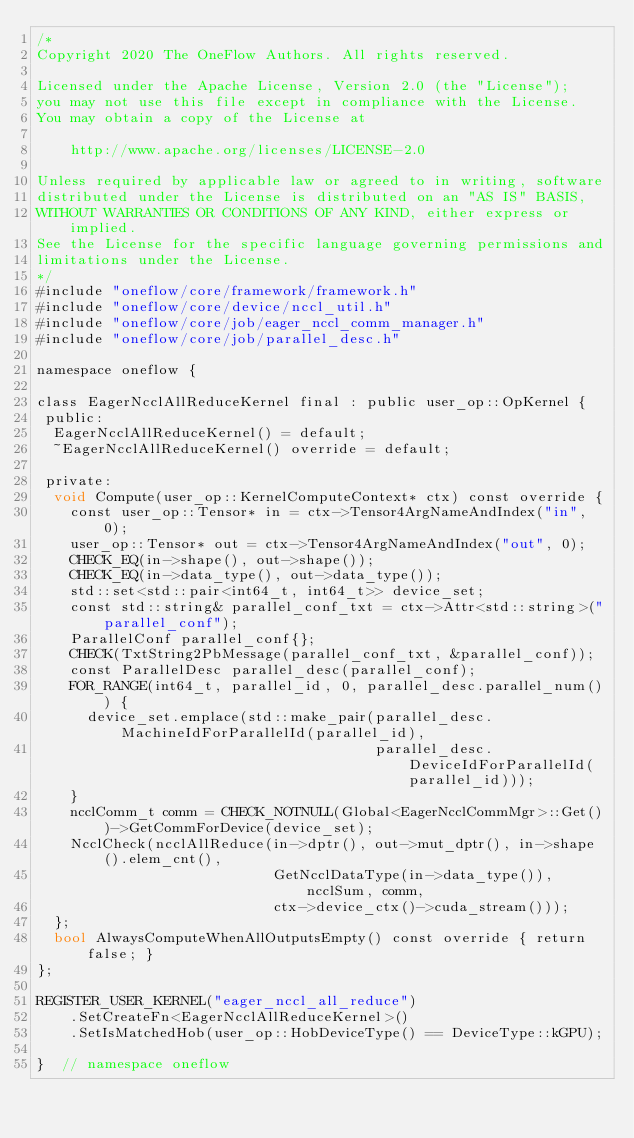Convert code to text. <code><loc_0><loc_0><loc_500><loc_500><_Cuda_>/*
Copyright 2020 The OneFlow Authors. All rights reserved.

Licensed under the Apache License, Version 2.0 (the "License");
you may not use this file except in compliance with the License.
You may obtain a copy of the License at

    http://www.apache.org/licenses/LICENSE-2.0

Unless required by applicable law or agreed to in writing, software
distributed under the License is distributed on an "AS IS" BASIS,
WITHOUT WARRANTIES OR CONDITIONS OF ANY KIND, either express or implied.
See the License for the specific language governing permissions and
limitations under the License.
*/
#include "oneflow/core/framework/framework.h"
#include "oneflow/core/device/nccl_util.h"
#include "oneflow/core/job/eager_nccl_comm_manager.h"
#include "oneflow/core/job/parallel_desc.h"

namespace oneflow {

class EagerNcclAllReduceKernel final : public user_op::OpKernel {
 public:
  EagerNcclAllReduceKernel() = default;
  ~EagerNcclAllReduceKernel() override = default;

 private:
  void Compute(user_op::KernelComputeContext* ctx) const override {
    const user_op::Tensor* in = ctx->Tensor4ArgNameAndIndex("in", 0);
    user_op::Tensor* out = ctx->Tensor4ArgNameAndIndex("out", 0);
    CHECK_EQ(in->shape(), out->shape());
    CHECK_EQ(in->data_type(), out->data_type());
    std::set<std::pair<int64_t, int64_t>> device_set;
    const std::string& parallel_conf_txt = ctx->Attr<std::string>("parallel_conf");
    ParallelConf parallel_conf{};
    CHECK(TxtString2PbMessage(parallel_conf_txt, &parallel_conf));
    const ParallelDesc parallel_desc(parallel_conf);
    FOR_RANGE(int64_t, parallel_id, 0, parallel_desc.parallel_num()) {
      device_set.emplace(std::make_pair(parallel_desc.MachineIdForParallelId(parallel_id),
                                        parallel_desc.DeviceIdForParallelId(parallel_id)));
    }
    ncclComm_t comm = CHECK_NOTNULL(Global<EagerNcclCommMgr>::Get())->GetCommForDevice(device_set);
    NcclCheck(ncclAllReduce(in->dptr(), out->mut_dptr(), in->shape().elem_cnt(),
                            GetNcclDataType(in->data_type()), ncclSum, comm,
                            ctx->device_ctx()->cuda_stream()));
  };
  bool AlwaysComputeWhenAllOutputsEmpty() const override { return false; }
};

REGISTER_USER_KERNEL("eager_nccl_all_reduce")
    .SetCreateFn<EagerNcclAllReduceKernel>()
    .SetIsMatchedHob(user_op::HobDeviceType() == DeviceType::kGPU);

}  // namespace oneflow
</code> 